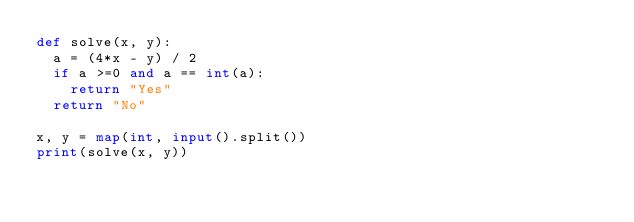Convert code to text. <code><loc_0><loc_0><loc_500><loc_500><_Python_>def solve(x, y):
	a = (4*x - y) / 2
	if a >=0 and a == int(a):
		return "Yes"
	return "No" 

x, y = map(int, input().split())
print(solve(x, y))</code> 